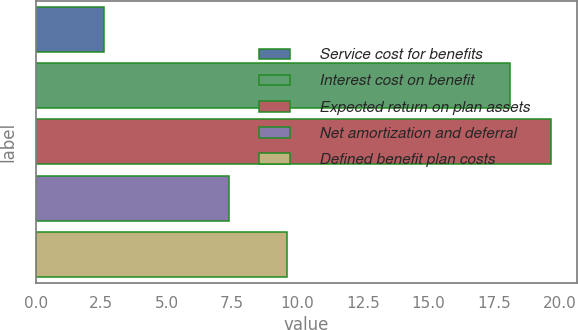Convert chart. <chart><loc_0><loc_0><loc_500><loc_500><bar_chart><fcel>Service cost for benefits<fcel>Interest cost on benefit<fcel>Expected return on plan assets<fcel>Net amortization and deferral<fcel>Defined benefit plan costs<nl><fcel>2.6<fcel>18.1<fcel>19.69<fcel>7.4<fcel>9.6<nl></chart> 